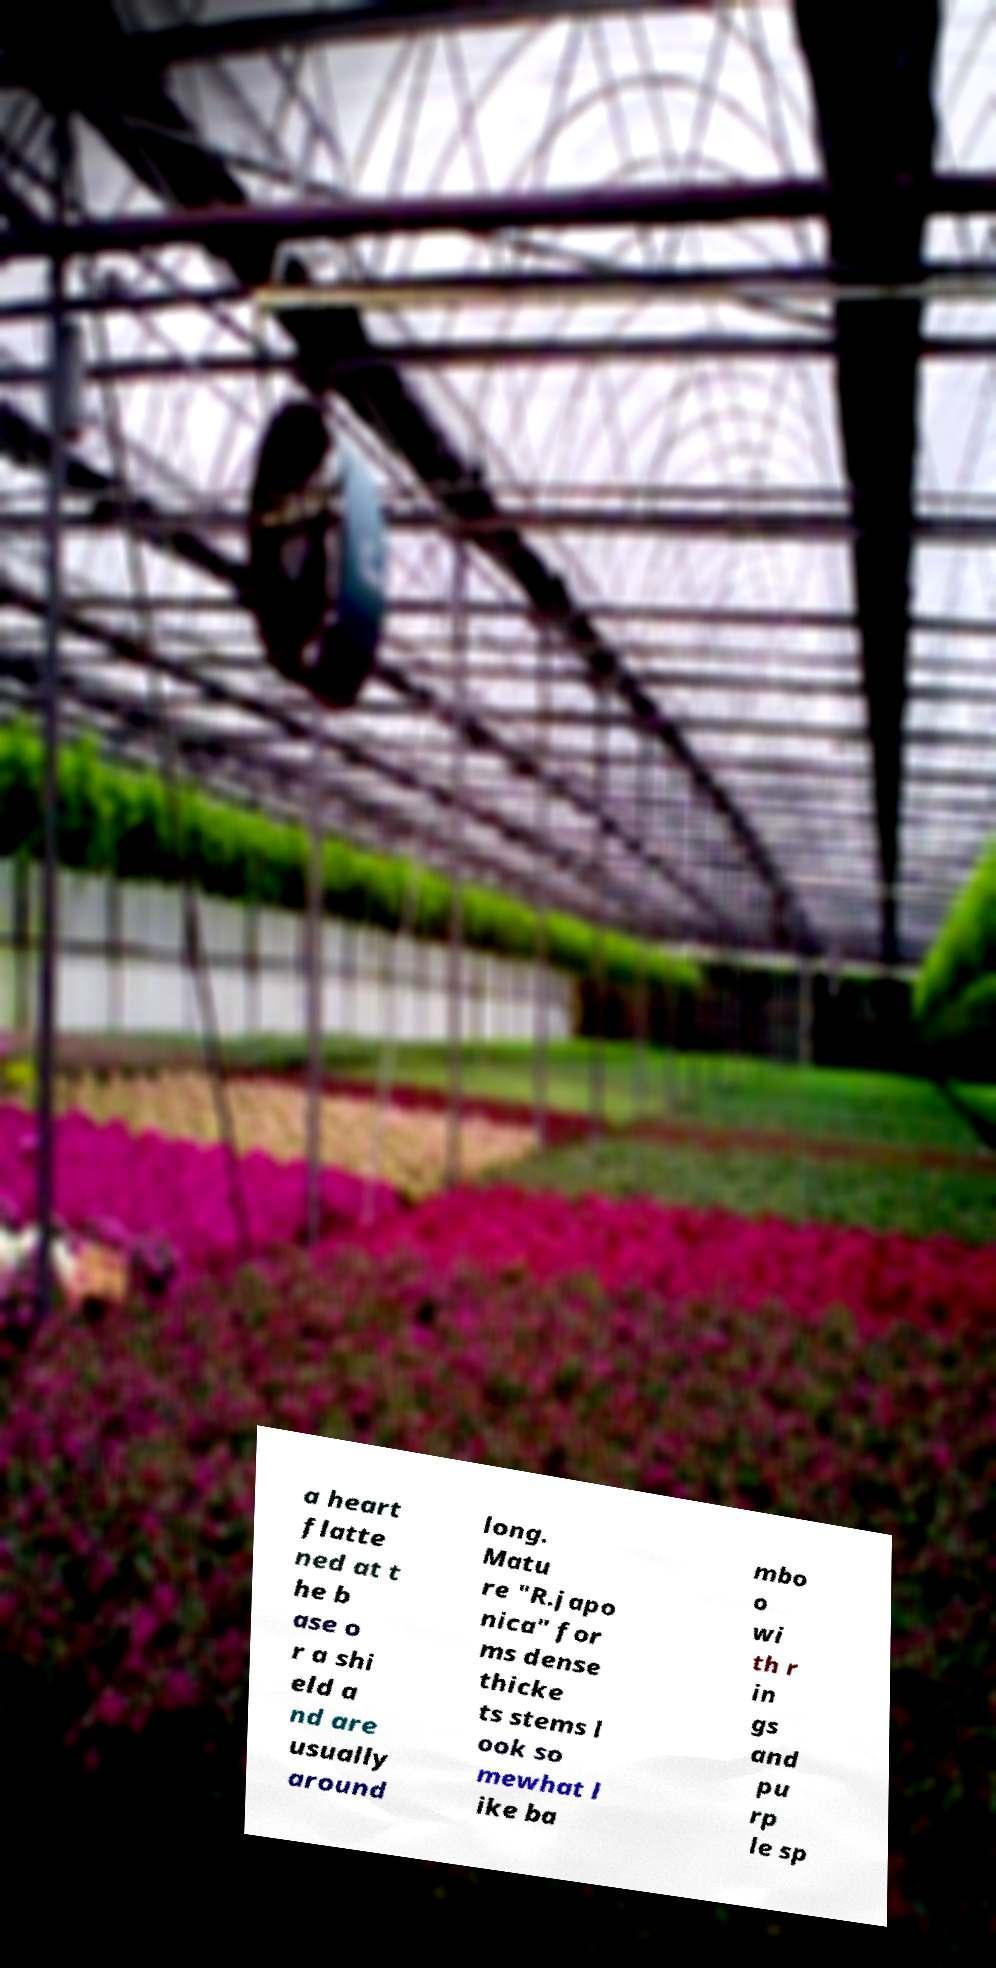Please identify and transcribe the text found in this image. a heart flatte ned at t he b ase o r a shi eld a nd are usually around long. Matu re "R.japo nica" for ms dense thicke ts stems l ook so mewhat l ike ba mbo o wi th r in gs and pu rp le sp 